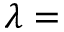<formula> <loc_0><loc_0><loc_500><loc_500>\lambda =</formula> 